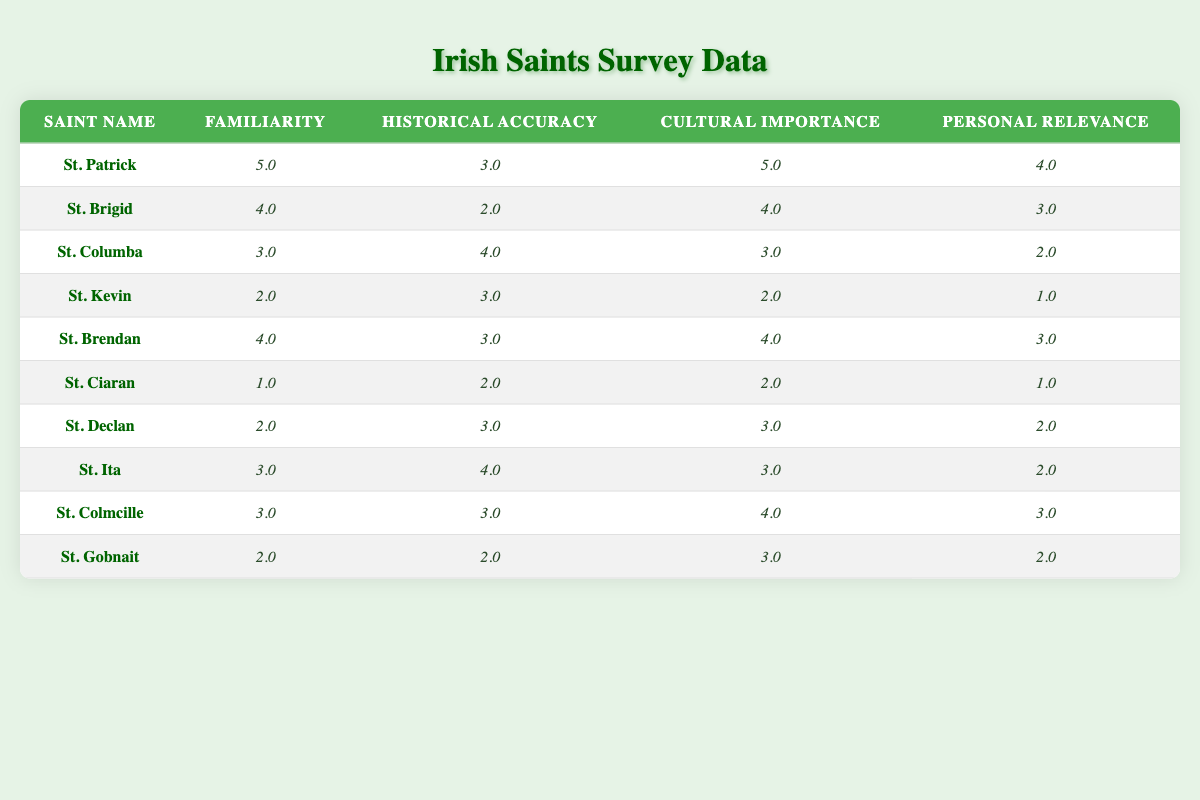What is the familiarity score for St. Patrick? Referring to the table, the familiarity score for St. Patrick is listed directly under the Familiarity column. It indicates that St. Patrick has a familiarity score of 5.0.
Answer: 5.0 What is the personal relevance score of St. Kevin? The personal relevance score for St. Kevin can be found in the corresponding row under the Personal Relevance column. It is listed as 1.0.
Answer: 1.0 Which saint has the highest cultural importance score? By examining the Cultural Importance column, St. Patrick has the highest score of 5.0, which is greater than any other saint's score.
Answer: St. Patrick What is the average historical accuracy score of St. Brigid and St. Brendan? The historical accuracy for St. Brigid is 2.0 and for St. Brendan is 3.0. To find the average, we add these scores together, 2.0 + 3.0 = 5.0, then divide by 2 to get 5.0 / 2 = 2.5.
Answer: 2.5 Does St. Ciaran have a higher cultural importance score than St. Gobnait? St. Ciaran's cultural importance score is 2.0, while St. Gobnait's is 3.0. Since 2.0 is less than 3.0, the statement is false.
Answer: No What is the difference in familiarity scores between St. Declan and St. Brendan? St. Declan has a familiarity score of 2.0 and St. Brendan has a score of 4.0. To find the difference, we subtract: 4.0 - 2.0 = 2.0.
Answer: 2.0 Which saint has a historical accuracy score of 4.0? Looking at the table, both St. Columba and St. Ita have a historical accuracy score of 4.0.
Answer: St. Columba, St. Ita What is the sum of the cultural importance scores for all saints? To calculate the sum, we add the cultural importance scores together: 5 + 4 + 3 + 2 + 4 + 2 + 3 + 3 + 4 + 3 = 33.
Answer: 33 Is the personal relevance score of St. Ita equal to its historical accuracy score? The personal relevance score of St. Ita is 2.0, and the historical accuracy score is 4.0, which are not equal. Therefore, the statement is false.
Answer: No 